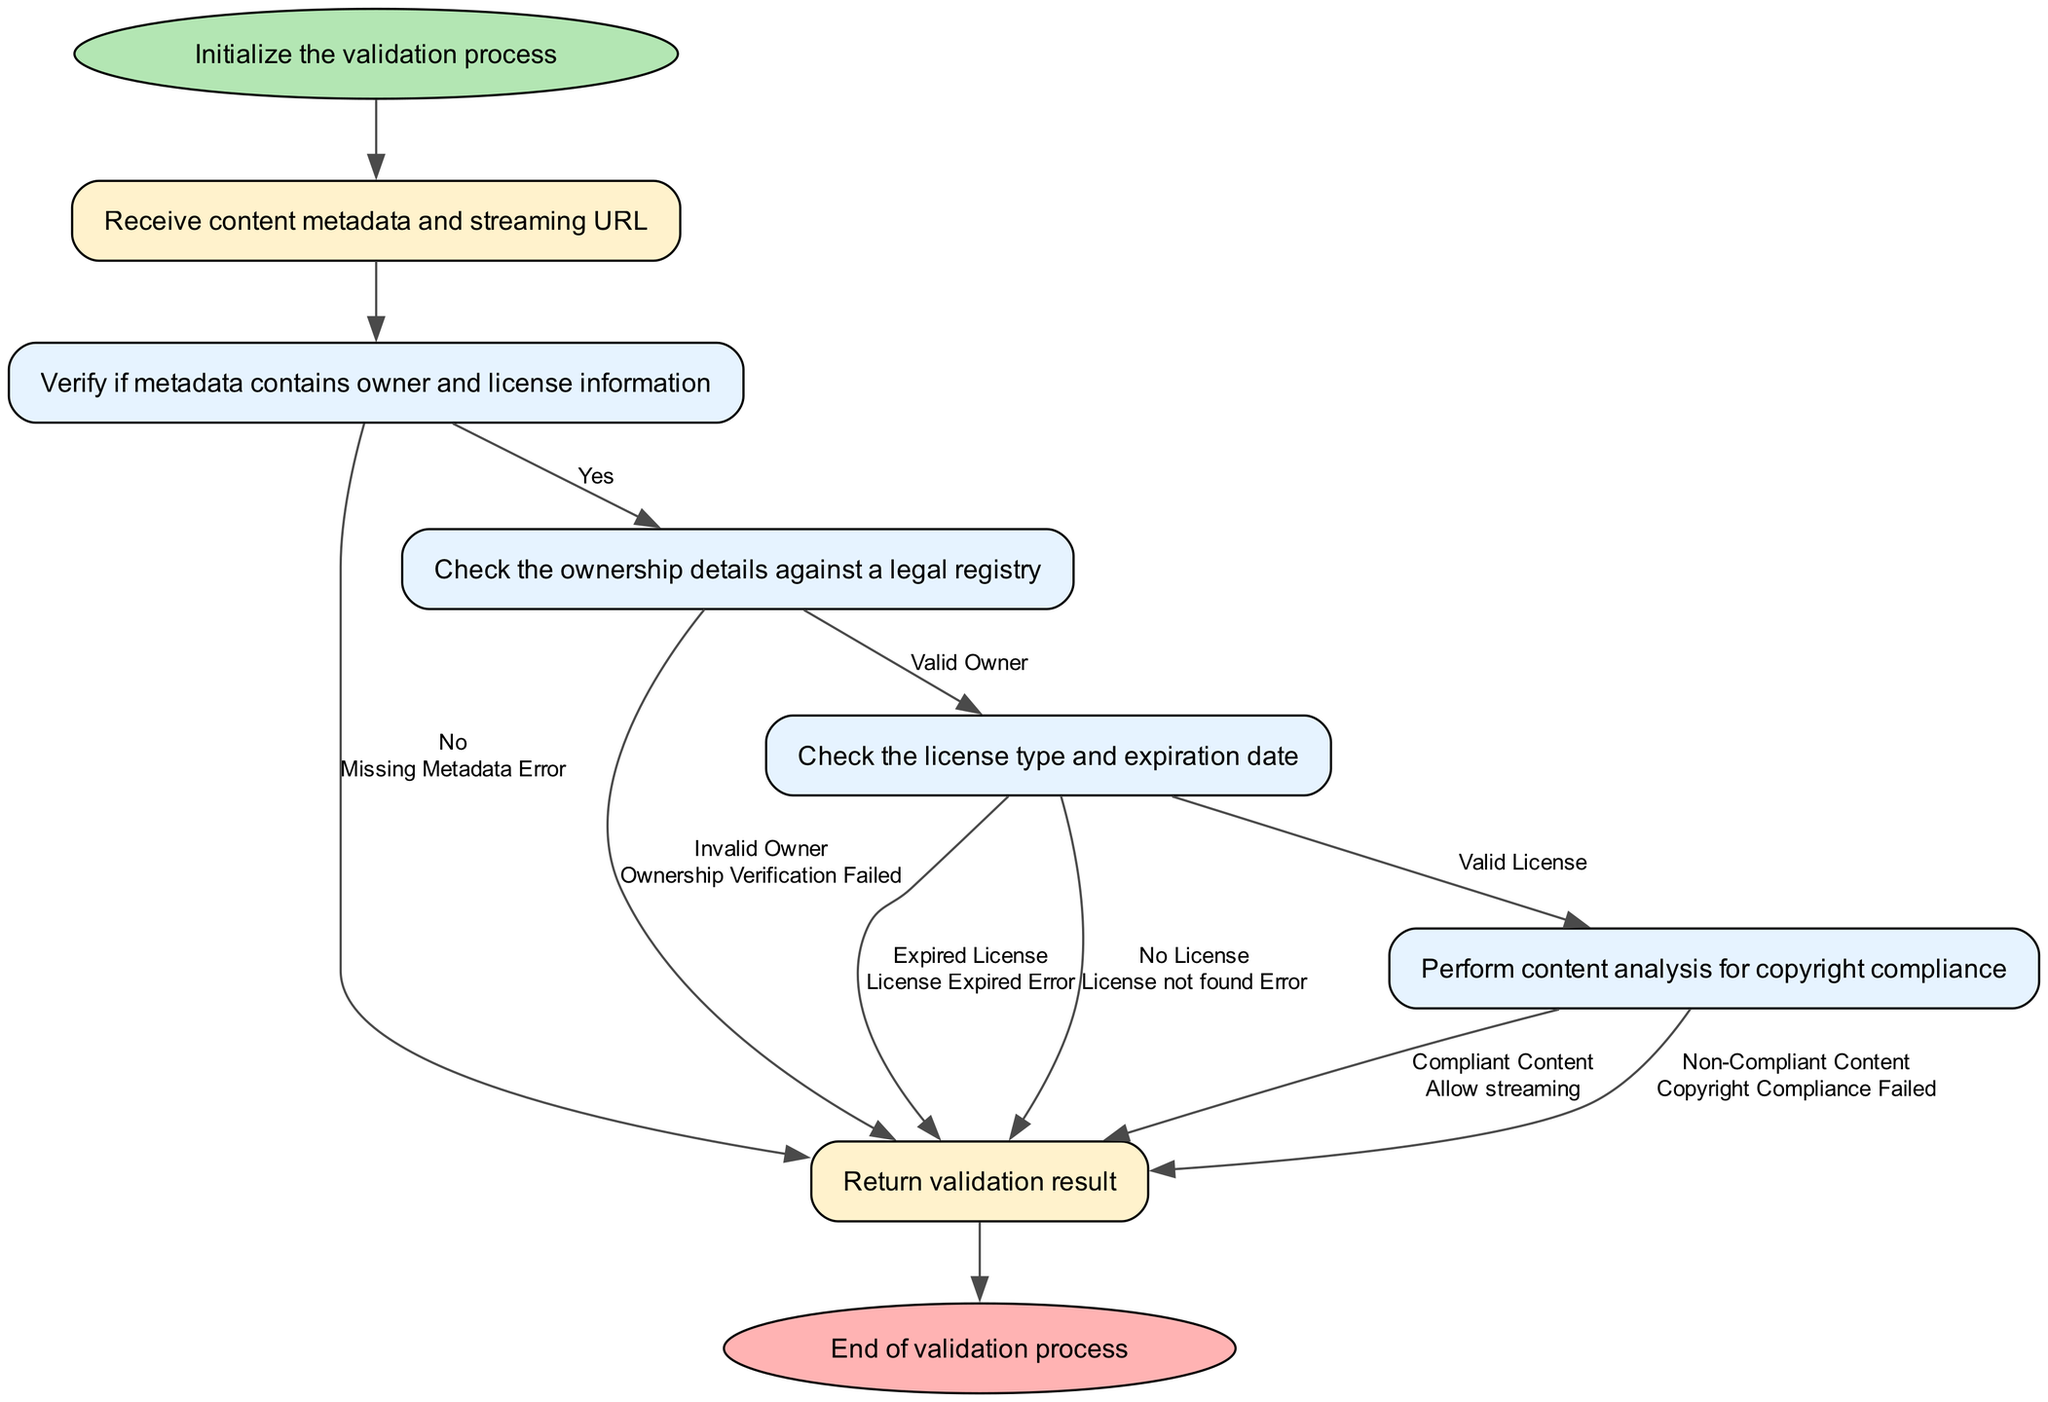What is the first step in the validation process? The first step in the validation process is represented by the 'Start' node, which initializes the validation process.
Answer: Initialize the validation process How many main process nodes are in the flowchart? The flowchart contains four main process nodes: Check Metadata, Verify Ownership, Verify License, and Analyze Content. Each represents a distinct verification step.
Answer: Four What happens if the metadata is missing? If the metadata is missing, the flowchart directs to the 'Output' node with the label 'Missing Metadata Error', which indicates an error in the validation process.
Answer: Return 'Missing Metadata Error' What is checked after verifying ownership? After verifying ownership, the process moves to the next node which checks the license type and expiration date in the verification process.
Answer: Verify License What are the two possible outcomes in the 'Analyze Content' node? The two possible outcomes in the 'Analyze Content' node are 'Compliant Content', allowing streaming, and 'Non-Compliant Content', indicating copyright compliance failure.
Answer: Compliant Content and Non-Compliant Content What does the flowchart return at the end of the validation process? At the end of the validation process, the flowchart leads to the 'Output' node, which returns the validation result based on the previous checks conducted.
Answer: Return validation result What would happen if the license is expired? If the license is expired, the flowchart indicates a transition to the 'Output' node with the label 'License Expired Error', indicating a failure in the validation.
Answer: Return 'License Expired Error' What is indicated if an invalid owner is found during ownership verification? If an invalid owner is found, the flowchart directs to the 'Output' node with the label 'Ownership Verification Failed', signaling a problem with ownership compliance.
Answer: Return 'Ownership Verification Failed' 